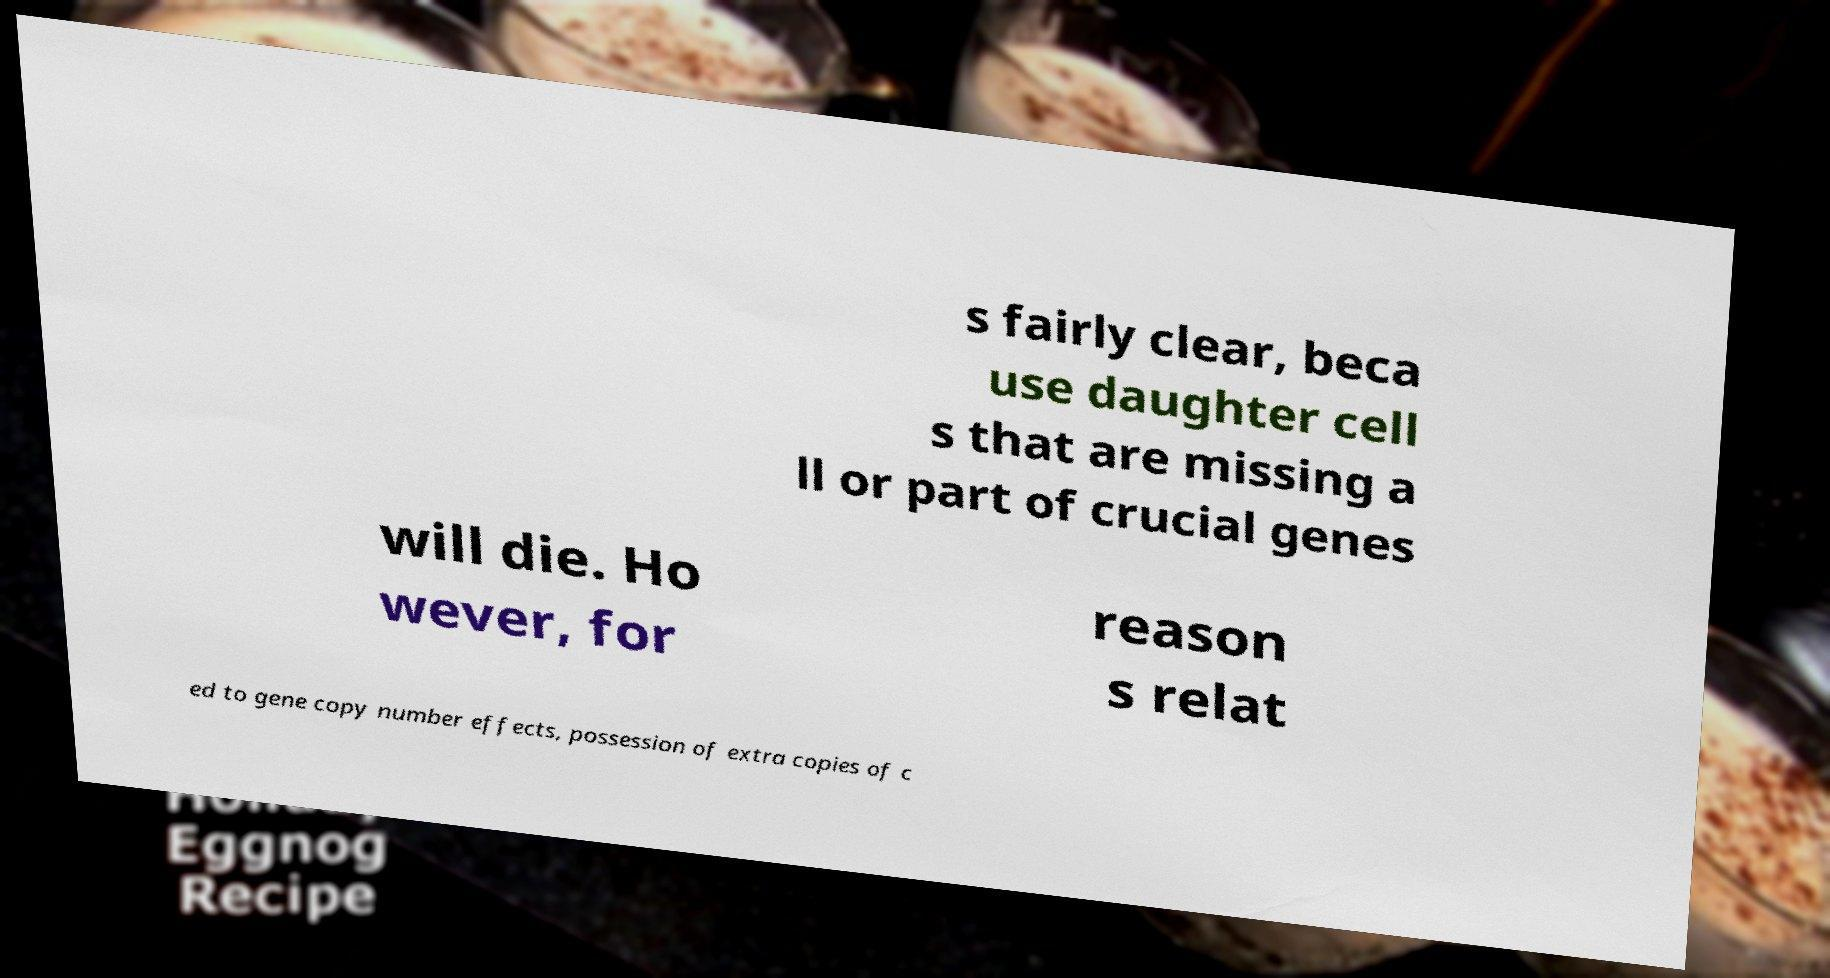What messages or text are displayed in this image? I need them in a readable, typed format. s fairly clear, beca use daughter cell s that are missing a ll or part of crucial genes will die. Ho wever, for reason s relat ed to gene copy number effects, possession of extra copies of c 